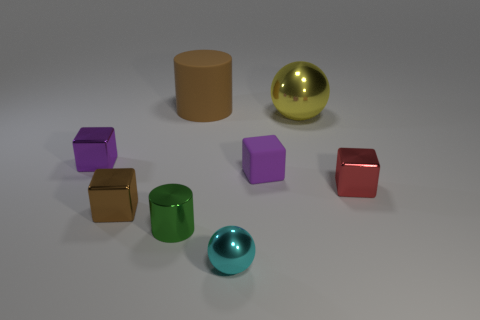Add 1 green blocks. How many objects exist? 9 Subtract all purple matte cubes. How many cubes are left? 3 Subtract all red cubes. How many cubes are left? 3 Subtract all spheres. How many objects are left? 6 Subtract all brown cubes. Subtract all green cylinders. How many cubes are left? 3 Add 6 yellow metal things. How many yellow metal things exist? 7 Subtract 1 red blocks. How many objects are left? 7 Subtract all balls. Subtract all tiny purple cubes. How many objects are left? 4 Add 2 small green cylinders. How many small green cylinders are left? 3 